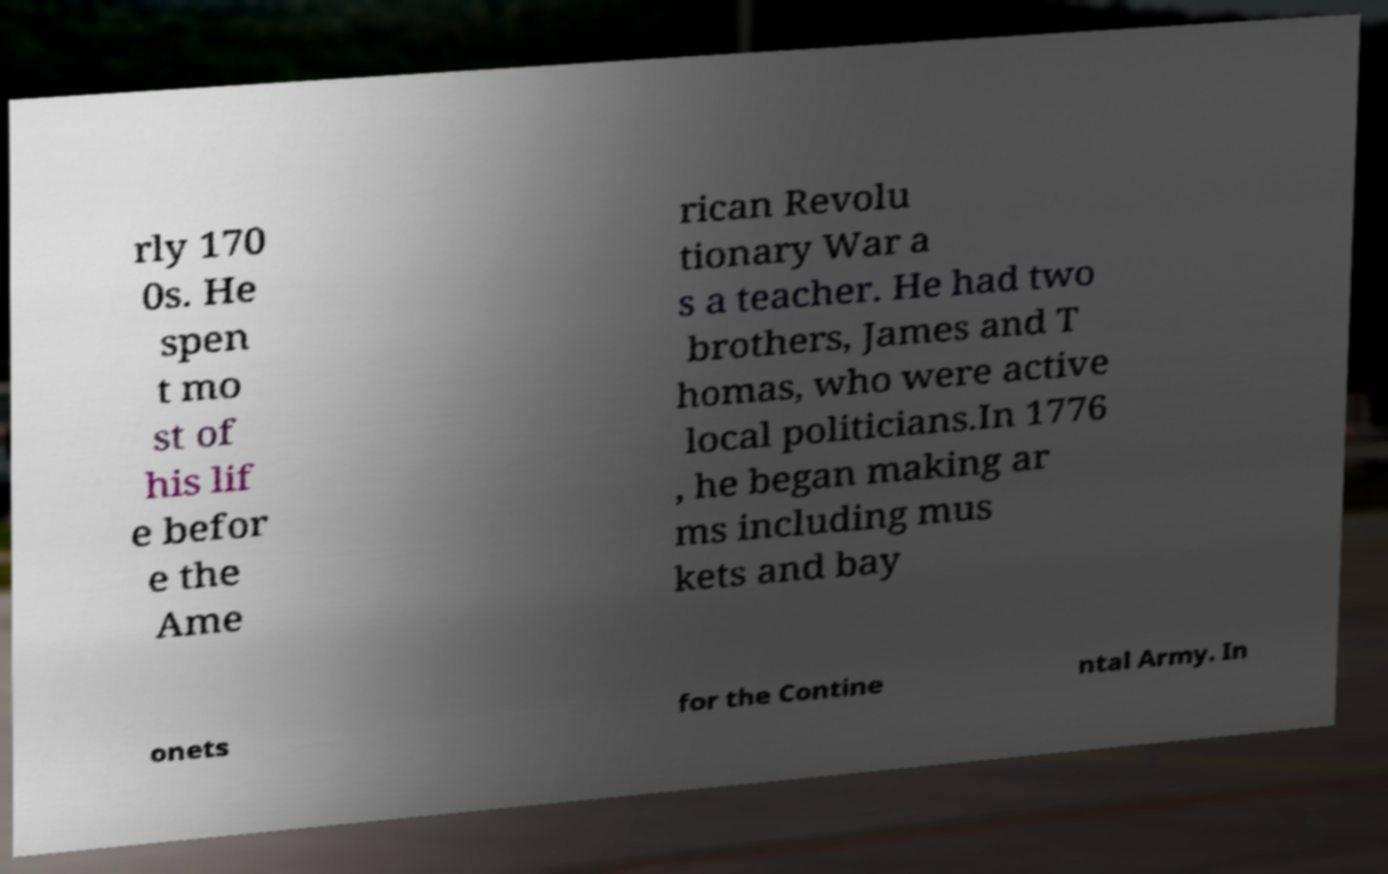I need the written content from this picture converted into text. Can you do that? rly 170 0s. He spen t mo st of his lif e befor e the Ame rican Revolu tionary War a s a teacher. He had two brothers, James and T homas, who were active local politicians.In 1776 , he began making ar ms including mus kets and bay onets for the Contine ntal Army. In 